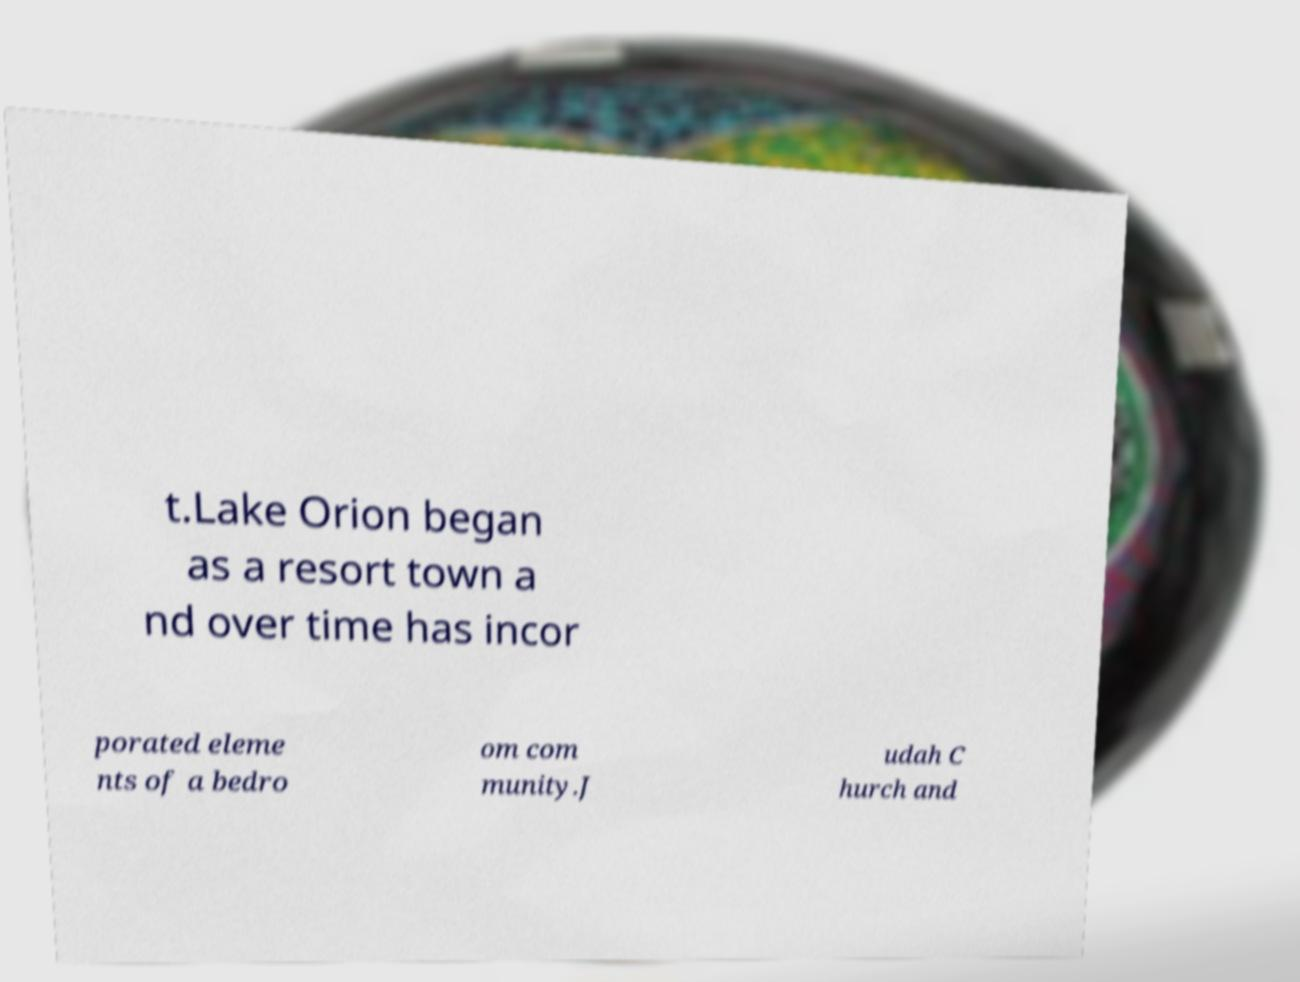There's text embedded in this image that I need extracted. Can you transcribe it verbatim? t.Lake Orion began as a resort town a nd over time has incor porated eleme nts of a bedro om com munity.J udah C hurch and 